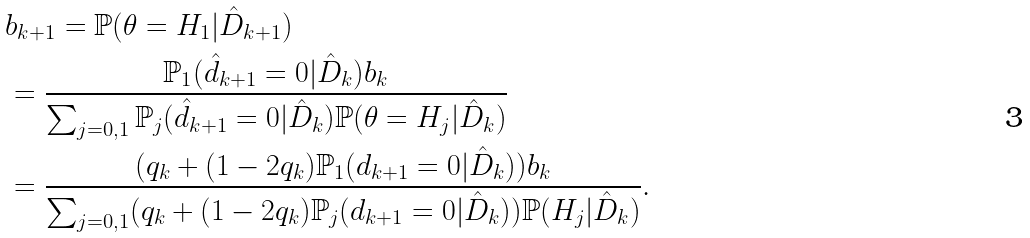Convert formula to latex. <formula><loc_0><loc_0><loc_500><loc_500>& b _ { k + 1 } = \mathbb { P } ( \theta = H _ { 1 } | \hat { D } _ { k + 1 } ) \\ & = \frac { \mathbb { P } _ { 1 } ( \hat { d } _ { k + 1 } = 0 | \hat { D } _ { k } ) b _ { k } } { \sum _ { j = 0 , 1 } \mathbb { P } _ { j } ( \hat { d } _ { k + 1 } = 0 | \hat { D } _ { k } ) \mathbb { P } ( \theta = H _ { j } | \hat { D } _ { k } ) } \\ & = \frac { ( q _ { k } + ( 1 - 2 q _ { k } ) \mathbb { P } _ { 1 } ( d _ { k + 1 } = 0 | \hat { D } _ { k } ) ) b _ { k } } { \sum _ { j = 0 , 1 } ( q _ { k } + ( 1 - 2 q _ { k } ) \mathbb { P } _ { j } ( d _ { k + 1 } = 0 | \hat { D } _ { k } ) ) \mathbb { P } ( H _ { j } | \hat { D } _ { k } ) } .</formula> 